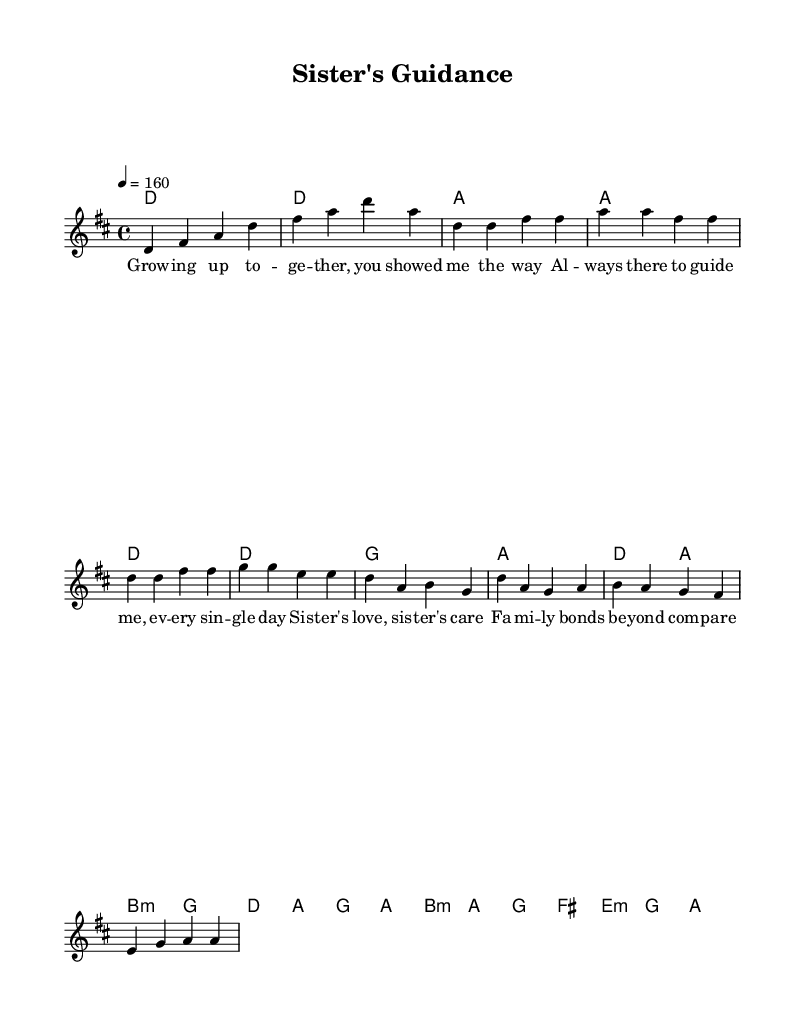What is the key signature of this music? The key signature is D major, which contains two sharps: F# and C#. This is evident from the key indication at the beginning of the score.
Answer: D major What is the time signature of this music? The time signature is 4/4, which is indicated at the beginning of the score. This means there are four beats in each measure and a quarter note gets one beat.
Answer: 4/4 What is the tempo marking of this piece? The tempo marking is 4 equals 160, indicating the speed of the piece. This means there are 160 quarter notes played in one minute, showing it has an upbeat tempo typical for punk music.
Answer: 160 Which chord appears in the chorus? In the chorus, the chords include D, A, B minor, and G. These are shown in the chord section corresponding to the melody notes during the chorus.
Answer: D, A, B minor, G How many measures are in the verse? The verse consists of four measures, as indicated by the repeated structure within the melody section labeled 'Verse 1'.
Answer: 4 measures What theme is emphasized in the lyrics? The lyrics emphasize family values and sibling relationships, as seen in the lines that talk about guidance and care provided by the sister.
Answer: Family values and sibling relationships What type of song structure does this piece follow? The piece follows a common pop-punk structure of verse, chorus, and bridge, which can be identified by the labeled sections in the sheet music.
Answer: Verse, chorus, bridge structure 